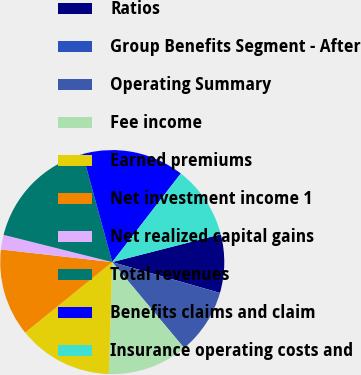Convert chart to OTSL. <chart><loc_0><loc_0><loc_500><loc_500><pie_chart><fcel>Ratios<fcel>Group Benefits Segment - After<fcel>Operating Summary<fcel>Fee income<fcel>Earned premiums<fcel>Net investment income 1<fcel>Net realized capital gains<fcel>Total revenues<fcel>Benefits claims and claim<fcel>Insurance operating costs and<nl><fcel>8.42%<fcel>0.01%<fcel>9.47%<fcel>11.58%<fcel>13.68%<fcel>12.63%<fcel>2.11%<fcel>16.84%<fcel>14.73%<fcel>10.53%<nl></chart> 